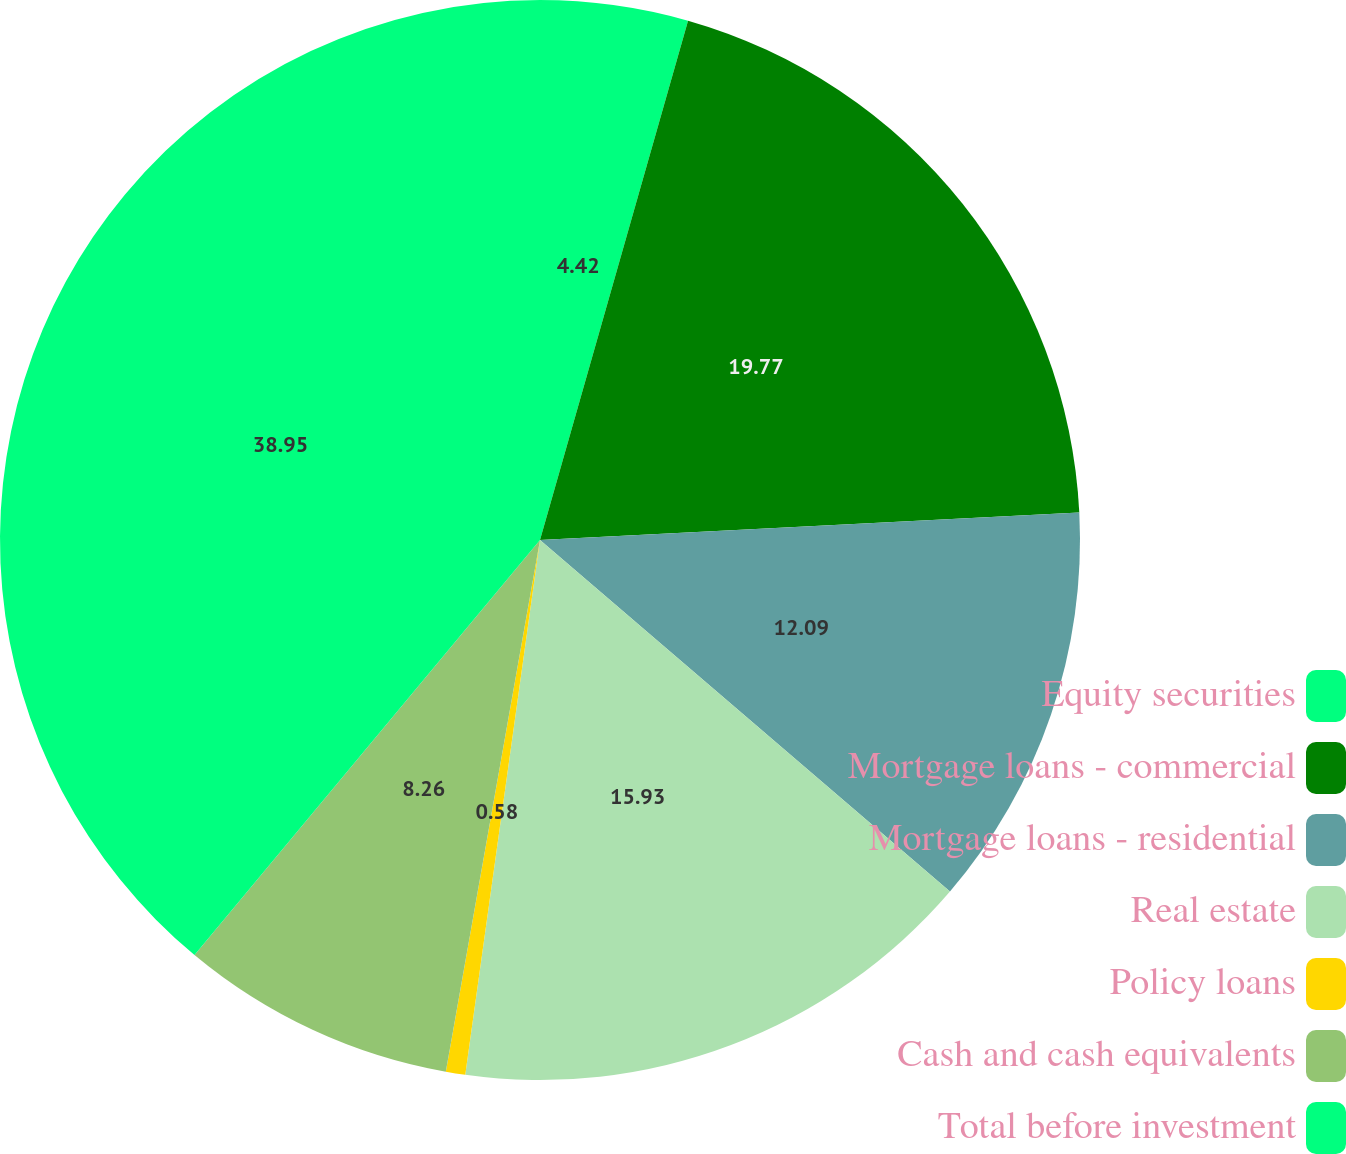Convert chart. <chart><loc_0><loc_0><loc_500><loc_500><pie_chart><fcel>Equity securities<fcel>Mortgage loans - commercial<fcel>Mortgage loans - residential<fcel>Real estate<fcel>Policy loans<fcel>Cash and cash equivalents<fcel>Total before investment<nl><fcel>4.42%<fcel>19.77%<fcel>12.09%<fcel>15.93%<fcel>0.58%<fcel>8.26%<fcel>38.95%<nl></chart> 